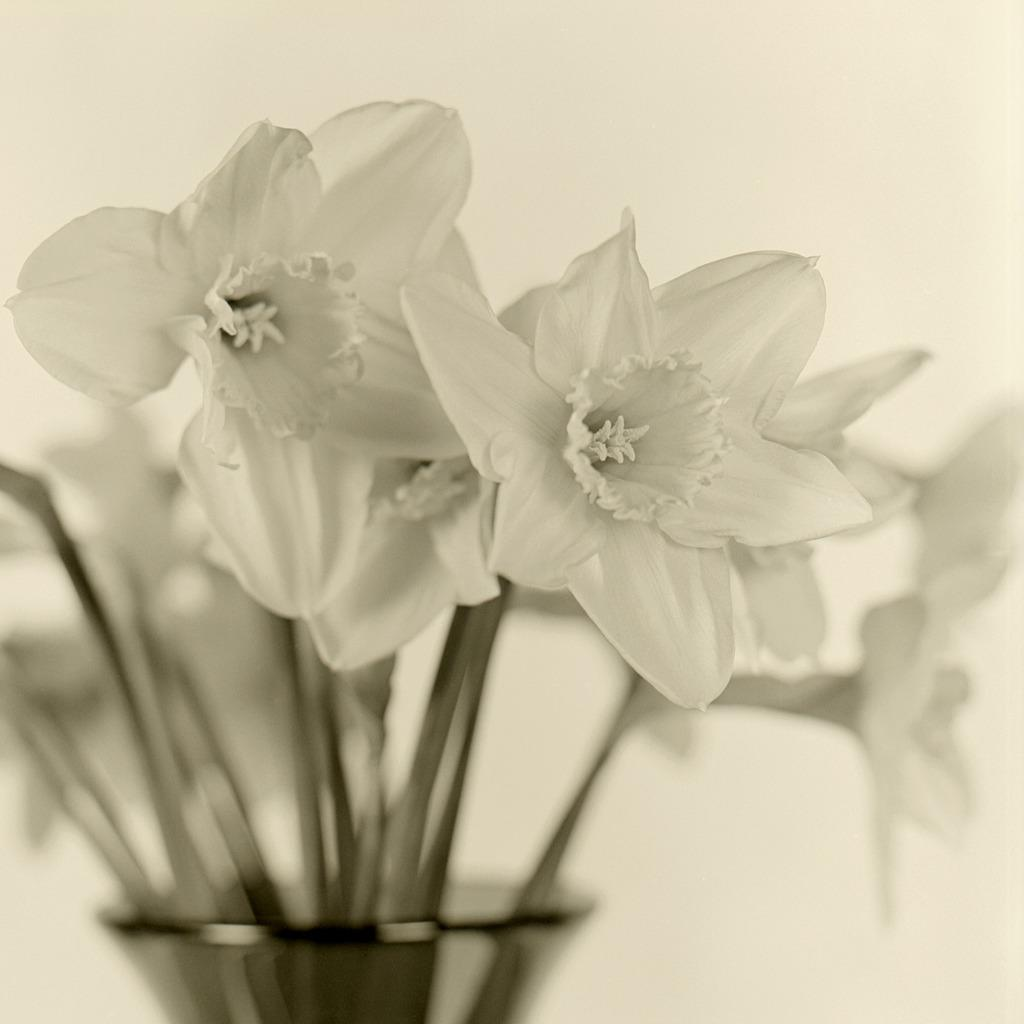What object is present in the image that holds plants? There is a flower pot in the image. What color are the flowers in the pot? The flowers in the pot are white in color. What can be seen in the background of the image? The background of the image is white. Is there a maid standing next to the sink in the image? There is no sink or maid present in the image. 